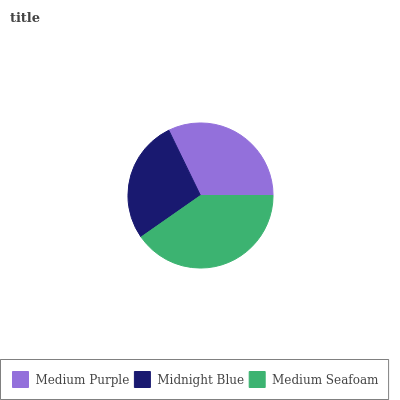Is Midnight Blue the minimum?
Answer yes or no. Yes. Is Medium Seafoam the maximum?
Answer yes or no. Yes. Is Medium Seafoam the minimum?
Answer yes or no. No. Is Midnight Blue the maximum?
Answer yes or no. No. Is Medium Seafoam greater than Midnight Blue?
Answer yes or no. Yes. Is Midnight Blue less than Medium Seafoam?
Answer yes or no. Yes. Is Midnight Blue greater than Medium Seafoam?
Answer yes or no. No. Is Medium Seafoam less than Midnight Blue?
Answer yes or no. No. Is Medium Purple the high median?
Answer yes or no. Yes. Is Medium Purple the low median?
Answer yes or no. Yes. Is Midnight Blue the high median?
Answer yes or no. No. Is Medium Seafoam the low median?
Answer yes or no. No. 